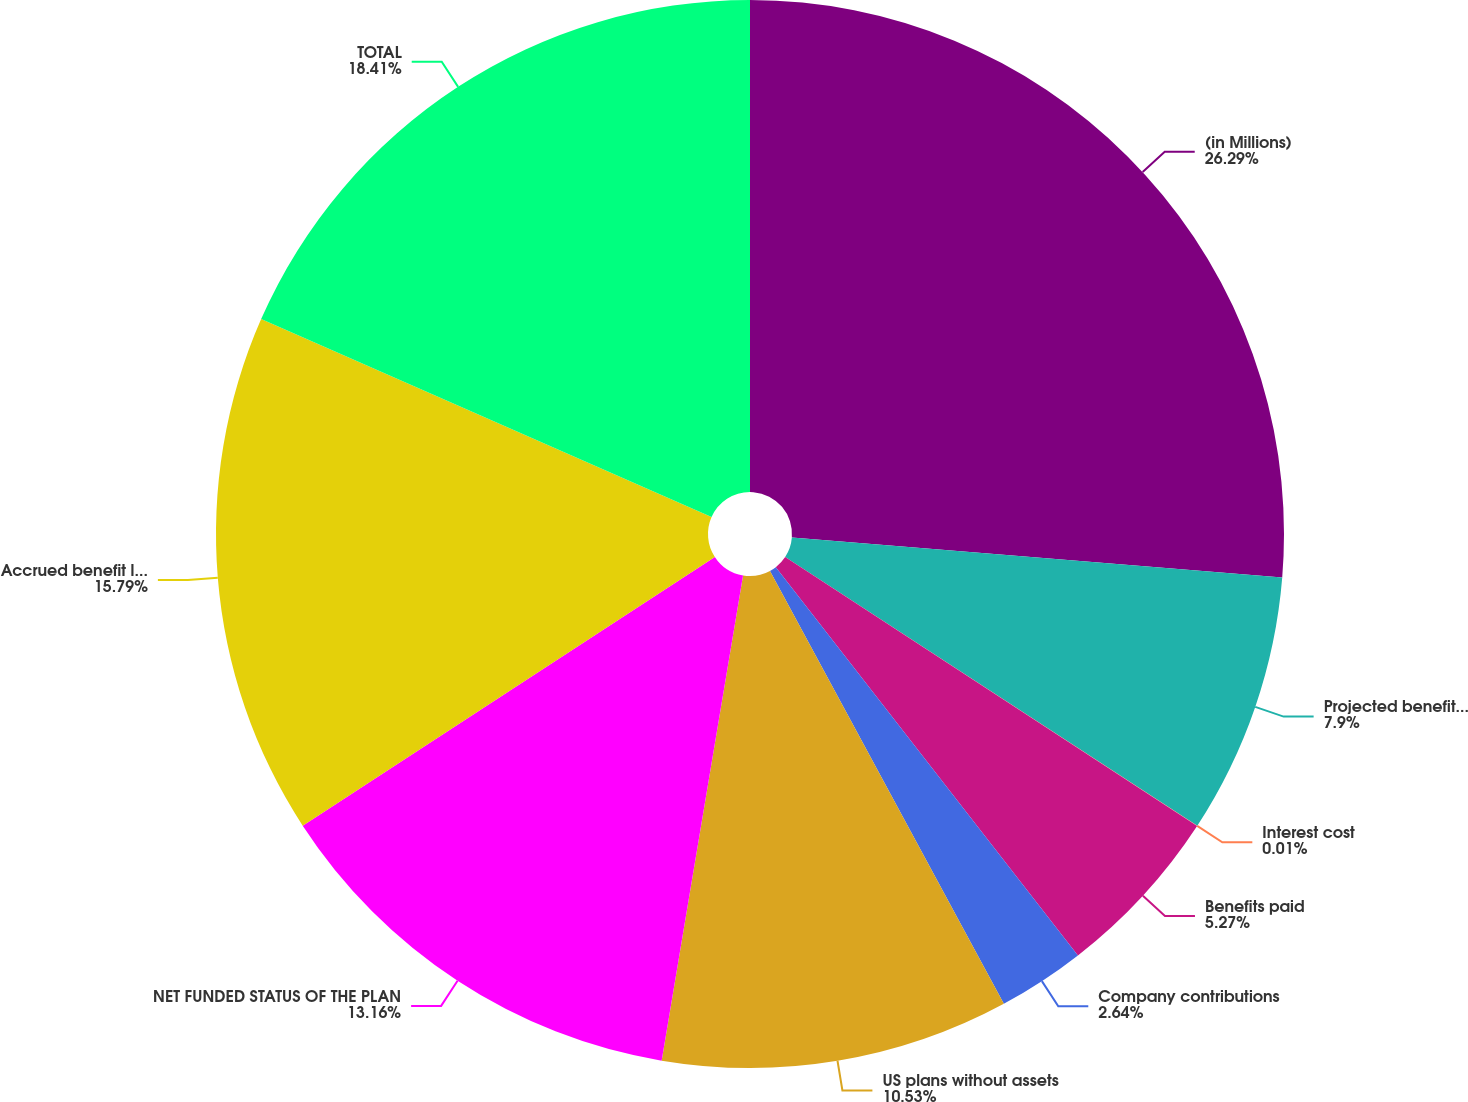Convert chart to OTSL. <chart><loc_0><loc_0><loc_500><loc_500><pie_chart><fcel>(in Millions)<fcel>Projected benefit obligation<fcel>Interest cost<fcel>Benefits paid<fcel>Company contributions<fcel>US plans without assets<fcel>NET FUNDED STATUS OF THE PLAN<fcel>Accrued benefit liability (2)<fcel>TOTAL<nl><fcel>26.3%<fcel>7.9%<fcel>0.01%<fcel>5.27%<fcel>2.64%<fcel>10.53%<fcel>13.16%<fcel>15.79%<fcel>18.41%<nl></chart> 